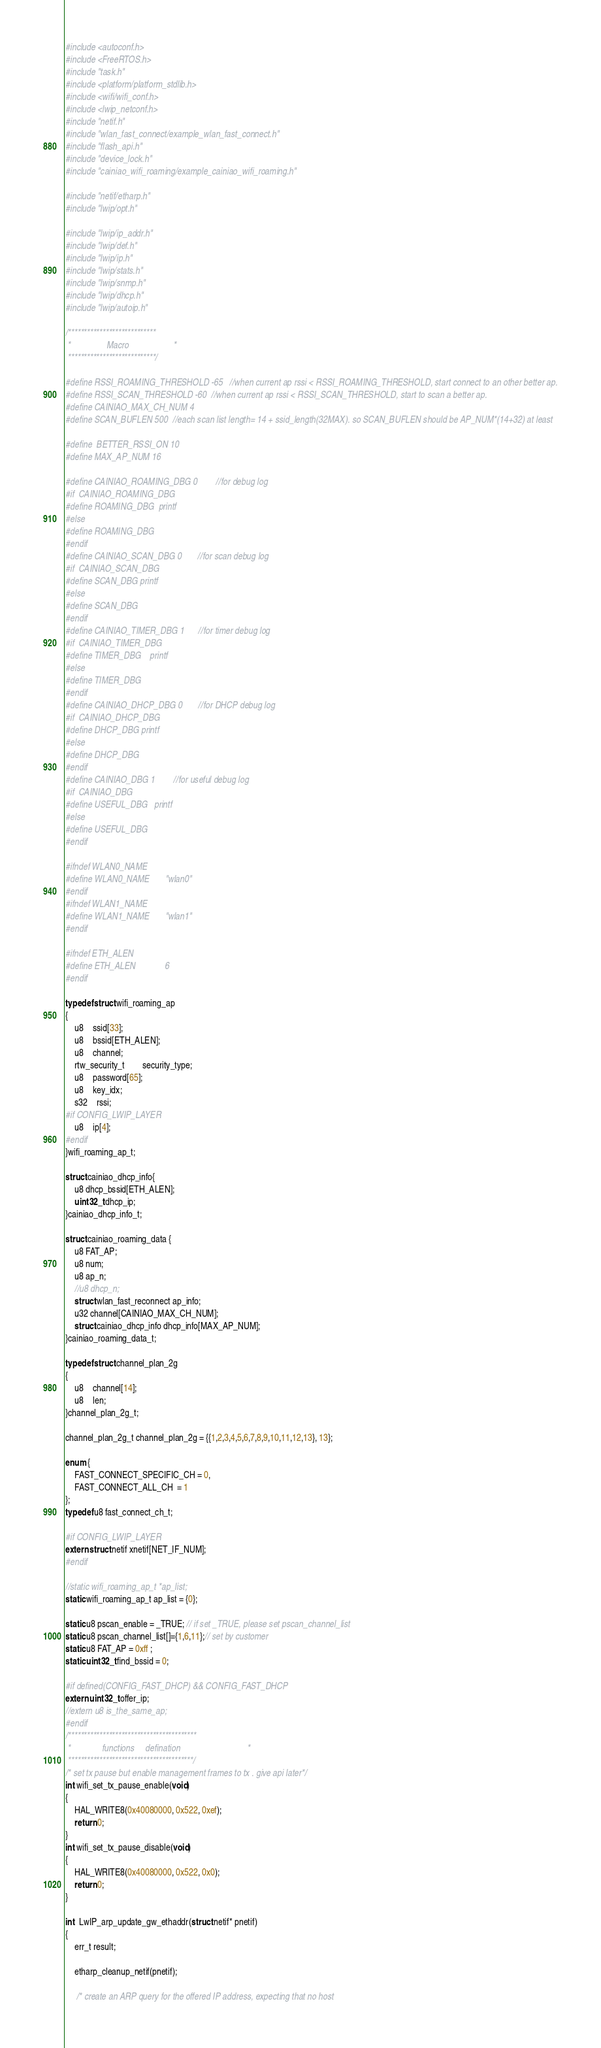<code> <loc_0><loc_0><loc_500><loc_500><_C_>#include <autoconf.h>
#include <FreeRTOS.h>
#include "task.h"
#include <platform/platform_stdlib.h>
#include <wifi/wifi_conf.h>
#include <lwip_netconf.h>
#include "netif.h"
#include "wlan_fast_connect/example_wlan_fast_connect.h"
#include "flash_api.h"
#include "device_lock.h"
#include "cainiao_wifi_roaming/example_cainiao_wifi_roaming.h"

#include "netif/etharp.h"
#include "lwip/opt.h"

#include "lwip/ip_addr.h"
#include "lwip/def.h"
#include "lwip/ip.h"
#include "lwip/stats.h"
#include "lwip/snmp.h"
#include "lwip/dhcp.h"
#include "lwip/autoip.h"

/****************************
 *                Macro                    *  
 ****************************/

#define RSSI_ROAMING_THRESHOLD -65	//when current ap rssi < RSSI_ROAMING_THRESHOLD, start connect to an other better ap.
#define RSSI_SCAN_THRESHOLD -60	//when current ap rssi < RSSI_SCAN_THRESHOLD, start to scan a better ap.
#define CAINIAO_MAX_CH_NUM 4
#define SCAN_BUFLEN 500 	//each scan list length= 14 + ssid_length(32MAX). so SCAN_BUFLEN should be AP_NUM*(14+32) at least

#define  BETTER_RSSI_ON 10
#define MAX_AP_NUM 16

#define CAINIAO_ROAMING_DBG 0 		//for debug log
#if	CAINIAO_ROAMING_DBG
#define ROAMING_DBG	printf
#else
#define ROAMING_DBG
#endif
#define CAINIAO_SCAN_DBG 0 		//for scan debug log
#if	CAINIAO_SCAN_DBG
#define SCAN_DBG	printf
#else
#define SCAN_DBG
#endif
#define CAINIAO_TIMER_DBG 1 		//for timer debug log
#if	CAINIAO_TIMER_DBG
#define TIMER_DBG	printf
#else
#define TIMER_DBG
#endif
#define CAINIAO_DHCP_DBG 0 		//for DHCP debug log
#if	CAINIAO_DHCP_DBG
#define DHCP_DBG	printf
#else
#define DHCP_DBG
#endif
#define CAINIAO_DBG 1 		//for useful debug log
#if	CAINIAO_DBG
#define USEFUL_DBG	printf
#else
#define USEFUL_DBG
#endif

#ifndef WLAN0_NAME
#define WLAN0_NAME		"wlan0"
#endif
#ifndef WLAN1_NAME
#define WLAN1_NAME		"wlan1"
#endif

#ifndef ETH_ALEN
#define ETH_ALEN 			6
#endif

typedef struct wifi_roaming_ap
{
	u8 	ssid[33];
	u8 	bssid[ETH_ALEN];
	u8	channel;
	rtw_security_t		security_type;
	u8 	password[65];
	u8	key_idx;
	s32	rssi;		
#if CONFIG_LWIP_LAYER
	u8	ip[4];
#endif
}wifi_roaming_ap_t;

struct cainiao_dhcp_info{
	u8 dhcp_bssid[ETH_ALEN];
	uint32_t dhcp_ip;
}cainiao_dhcp_info_t;

struct cainiao_roaming_data {
	u8 FAT_AP;
	u8 num;
	u8 ap_n;
	//u8 dhcp_n;
	struct wlan_fast_reconnect ap_info;
	u32 channel[CAINIAO_MAX_CH_NUM];	
	struct cainiao_dhcp_info dhcp_info[MAX_AP_NUM];	
}cainiao_roaming_data_t;

typedef struct channel_plan_2g
{
	u8	channel[14];
	u8	len;
}channel_plan_2g_t;

channel_plan_2g_t channel_plan_2g = {{1,2,3,4,5,6,7,8,9,10,11,12,13}, 13};

enum {
	FAST_CONNECT_SPECIFIC_CH = 0,
	FAST_CONNECT_ALL_CH  = 1
};
typedef u8 fast_connect_ch_t;

#if CONFIG_LWIP_LAYER
extern struct netif xnetif[NET_IF_NUM]; 
#endif

//static wifi_roaming_ap_t *ap_list;
static wifi_roaming_ap_t ap_list = {0};

static u8 pscan_enable = _TRUE; // if set _TRUE, please set pscan_channel_list
static u8 pscan_channel_list[]={1,6,11};// set by customer
static u8 FAT_AP = 0xff ;
static uint32_t find_bssid = 0;

#if defined(CONFIG_FAST_DHCP) && CONFIG_FAST_DHCP
extern uint32_t offer_ip;
//extern u8 is_the_same_ap;
#endif
/*****************************************
 *              functions     defination                              *
 ****************************************/
/* set tx pause but enable management frames to tx . give api later*/
int wifi_set_tx_pause_enable(void)
{
	HAL_WRITE8(0x40080000, 0x522, 0xef);
	return 0;
}
int wifi_set_tx_pause_disable(void)
{
	HAL_WRITE8(0x40080000, 0x522, 0x0);
	return 0;
}

int  LwIP_arp_update_gw_ethaddr(struct netif* pnetif)
{
	err_t result;

	etharp_cleanup_netif(pnetif);
	
	 /* create an ARP query for the offered IP address, expecting that no host</code> 